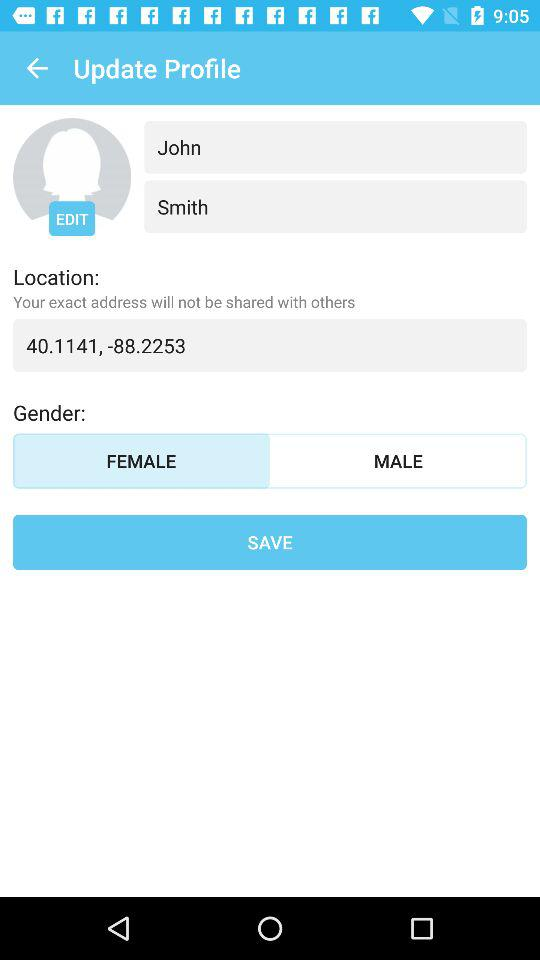What are the coordinates of the location? The coordinates of the location are 40.1141 and -88.2253. 